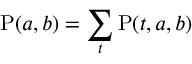Convert formula to latex. <formula><loc_0><loc_0><loc_500><loc_500>P ( a , b ) = \sum _ { t } P ( t , a , b )</formula> 